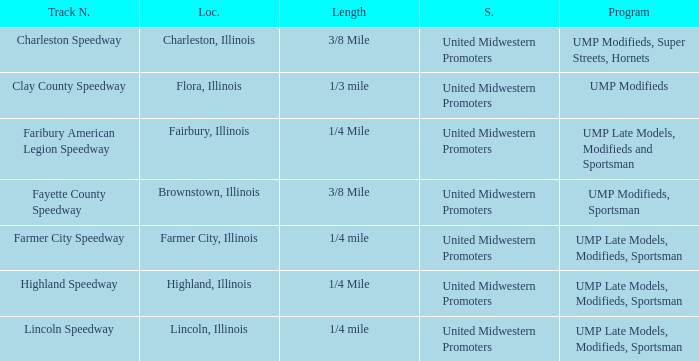What programs were held at highland speedway? UMP Late Models, Modifieds, Sportsman. 